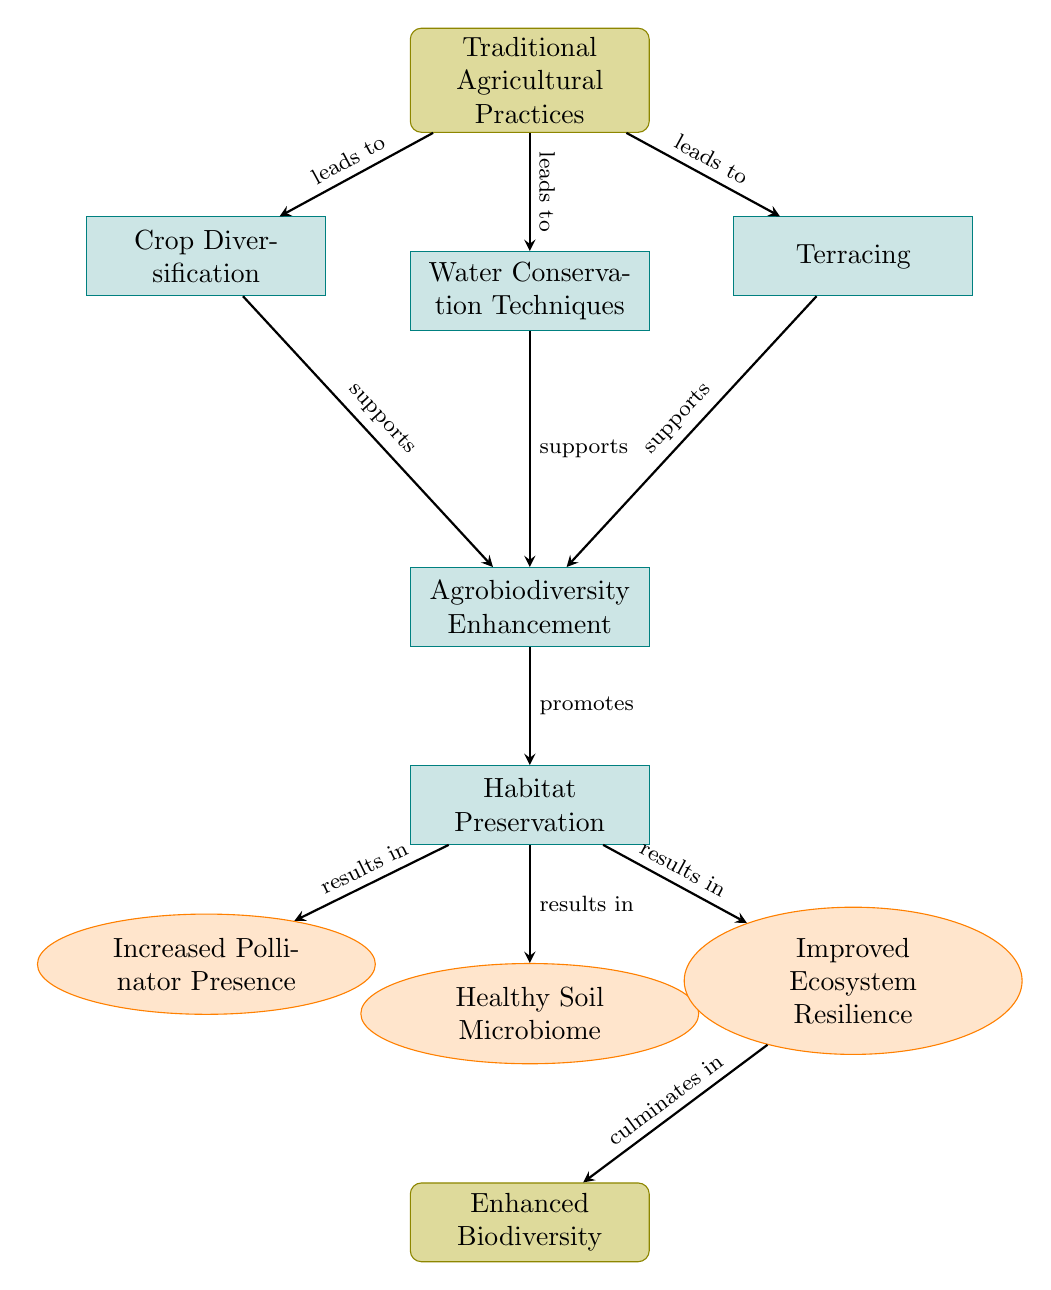What is the first node in the flow chart? The flow chart begins with the node labeled "Traditional Agricultural Practices," which is the starting point of the diagram.
Answer: Traditional Agricultural Practices How many outcome nodes exist in the diagram? There are three nodes categorized as "outcome," which are "Increased Pollinator Presence," "Healthy Soil Microbiome," and "Improved Ecosystem Resilience."
Answer: 3 What does "Crop Diversification" support? The node "Crop Diversification" directly supports the node "Agrobiodiversity Enhancement," as indicated by the connecting arrow in the diagram.
Answer: Agrobiodiversity Enhancement What is the last node in this flow chart? The final node, or endpoint, of the flow chart is labeled "Enhanced Biodiversity," which culminates from prior processes.
Answer: Enhanced Biodiversity What are the three outputs resulting from habitat preservation? The outputs resulting from "Habitat Preservation" are "Increased Pollinator Presence," "Healthy Soil Microbiome," and "Improved Ecosystem Resilience," each linked with an arrow indicating the result of the previous process.
Answer: Increased Pollinator Presence, Healthy Soil Microbiome, Improved Ecosystem Resilience What supports "Agrobiodiversity Enhancement"? "Agrobiodiversity Enhancement" is supported by three processes: "Crop Diversification," "Water Conservation Techniques," and "Terracing," each directly leading into it.
Answer: Crop Diversification, Water Conservation Techniques, Terracing What culminates from "Improved Ecosystem Resilience"? The process of "Improved Ecosystem Resilience" culminates in the final outcome node labeled "Enhanced Biodiversity," as shown by the connecting arrow in the diagram.
Answer: Enhanced Biodiversity 